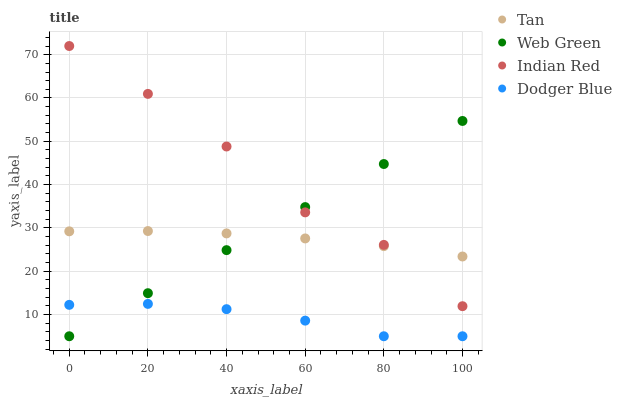Does Dodger Blue have the minimum area under the curve?
Answer yes or no. Yes. Does Indian Red have the maximum area under the curve?
Answer yes or no. Yes. Does Indian Red have the minimum area under the curve?
Answer yes or no. No. Does Dodger Blue have the maximum area under the curve?
Answer yes or no. No. Is Web Green the smoothest?
Answer yes or no. Yes. Is Indian Red the roughest?
Answer yes or no. Yes. Is Dodger Blue the smoothest?
Answer yes or no. No. Is Dodger Blue the roughest?
Answer yes or no. No. Does Dodger Blue have the lowest value?
Answer yes or no. Yes. Does Indian Red have the lowest value?
Answer yes or no. No. Does Indian Red have the highest value?
Answer yes or no. Yes. Does Dodger Blue have the highest value?
Answer yes or no. No. Is Dodger Blue less than Indian Red?
Answer yes or no. Yes. Is Tan greater than Dodger Blue?
Answer yes or no. Yes. Does Tan intersect Indian Red?
Answer yes or no. Yes. Is Tan less than Indian Red?
Answer yes or no. No. Is Tan greater than Indian Red?
Answer yes or no. No. Does Dodger Blue intersect Indian Red?
Answer yes or no. No. 